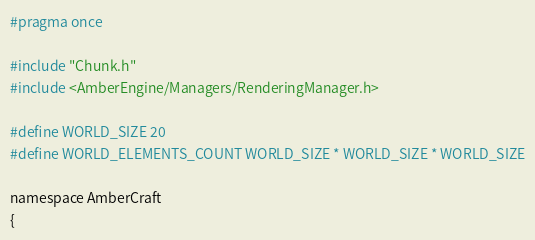Convert code to text. <code><loc_0><loc_0><loc_500><loc_500><_C_>#pragma once

#include "Chunk.h"
#include <AmberEngine/Managers/RenderingManager.h>

#define WORLD_SIZE 20
#define WORLD_ELEMENTS_COUNT WORLD_SIZE * WORLD_SIZE * WORLD_SIZE

namespace AmberCraft
{</code> 